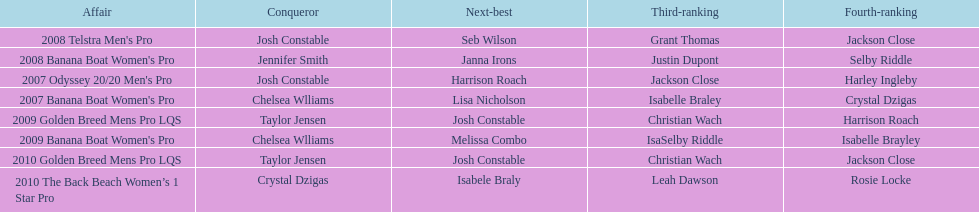In the 2008 telstra men's pro, who finished right after josh constable? Seb Wilson. 